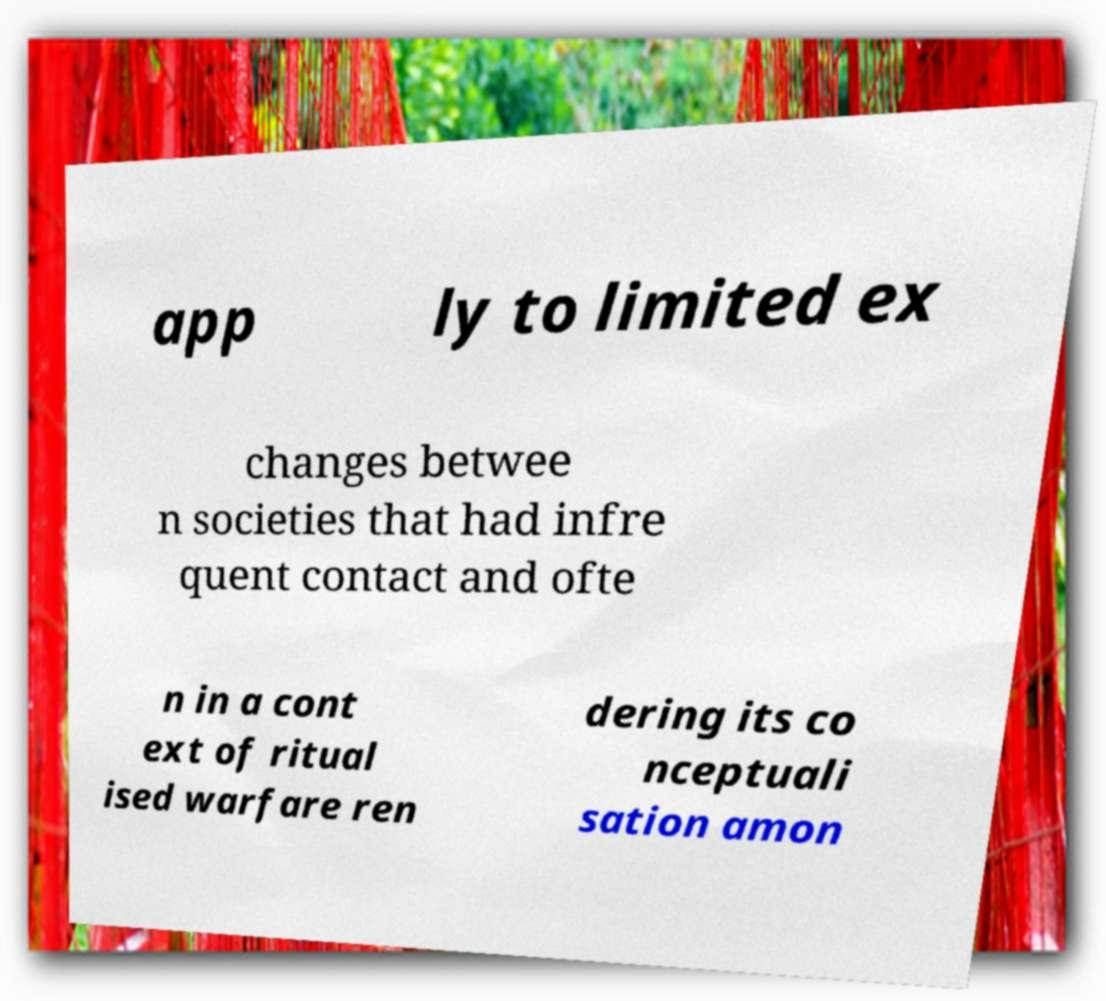Please identify and transcribe the text found in this image. app ly to limited ex changes betwee n societies that had infre quent contact and ofte n in a cont ext of ritual ised warfare ren dering its co nceptuali sation amon 